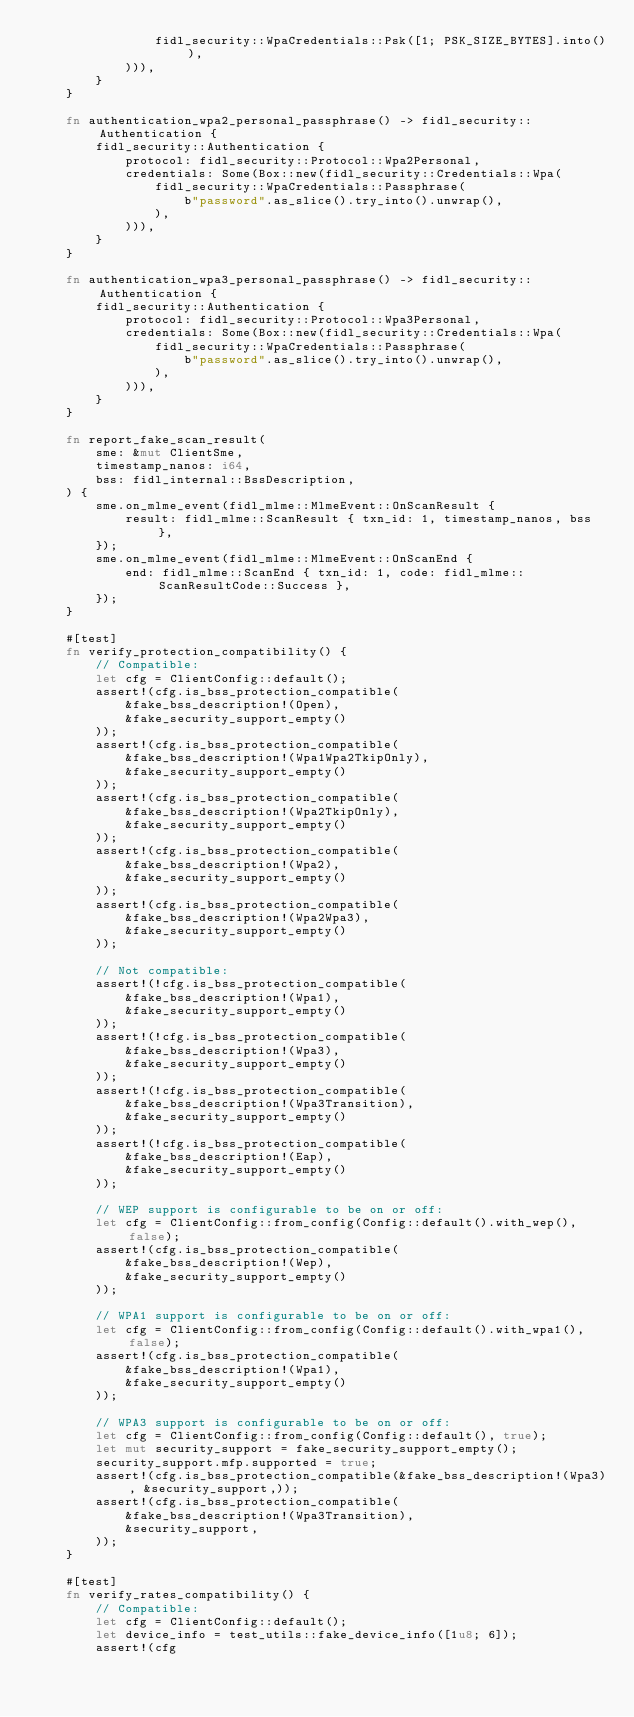<code> <loc_0><loc_0><loc_500><loc_500><_Rust_>                fidl_security::WpaCredentials::Psk([1; PSK_SIZE_BYTES].into()),
            ))),
        }
    }

    fn authentication_wpa2_personal_passphrase() -> fidl_security::Authentication {
        fidl_security::Authentication {
            protocol: fidl_security::Protocol::Wpa2Personal,
            credentials: Some(Box::new(fidl_security::Credentials::Wpa(
                fidl_security::WpaCredentials::Passphrase(
                    b"password".as_slice().try_into().unwrap(),
                ),
            ))),
        }
    }

    fn authentication_wpa3_personal_passphrase() -> fidl_security::Authentication {
        fidl_security::Authentication {
            protocol: fidl_security::Protocol::Wpa3Personal,
            credentials: Some(Box::new(fidl_security::Credentials::Wpa(
                fidl_security::WpaCredentials::Passphrase(
                    b"password".as_slice().try_into().unwrap(),
                ),
            ))),
        }
    }

    fn report_fake_scan_result(
        sme: &mut ClientSme,
        timestamp_nanos: i64,
        bss: fidl_internal::BssDescription,
    ) {
        sme.on_mlme_event(fidl_mlme::MlmeEvent::OnScanResult {
            result: fidl_mlme::ScanResult { txn_id: 1, timestamp_nanos, bss },
        });
        sme.on_mlme_event(fidl_mlme::MlmeEvent::OnScanEnd {
            end: fidl_mlme::ScanEnd { txn_id: 1, code: fidl_mlme::ScanResultCode::Success },
        });
    }

    #[test]
    fn verify_protection_compatibility() {
        // Compatible:
        let cfg = ClientConfig::default();
        assert!(cfg.is_bss_protection_compatible(
            &fake_bss_description!(Open),
            &fake_security_support_empty()
        ));
        assert!(cfg.is_bss_protection_compatible(
            &fake_bss_description!(Wpa1Wpa2TkipOnly),
            &fake_security_support_empty()
        ));
        assert!(cfg.is_bss_protection_compatible(
            &fake_bss_description!(Wpa2TkipOnly),
            &fake_security_support_empty()
        ));
        assert!(cfg.is_bss_protection_compatible(
            &fake_bss_description!(Wpa2),
            &fake_security_support_empty()
        ));
        assert!(cfg.is_bss_protection_compatible(
            &fake_bss_description!(Wpa2Wpa3),
            &fake_security_support_empty()
        ));

        // Not compatible:
        assert!(!cfg.is_bss_protection_compatible(
            &fake_bss_description!(Wpa1),
            &fake_security_support_empty()
        ));
        assert!(!cfg.is_bss_protection_compatible(
            &fake_bss_description!(Wpa3),
            &fake_security_support_empty()
        ));
        assert!(!cfg.is_bss_protection_compatible(
            &fake_bss_description!(Wpa3Transition),
            &fake_security_support_empty()
        ));
        assert!(!cfg.is_bss_protection_compatible(
            &fake_bss_description!(Eap),
            &fake_security_support_empty()
        ));

        // WEP support is configurable to be on or off:
        let cfg = ClientConfig::from_config(Config::default().with_wep(), false);
        assert!(cfg.is_bss_protection_compatible(
            &fake_bss_description!(Wep),
            &fake_security_support_empty()
        ));

        // WPA1 support is configurable to be on or off:
        let cfg = ClientConfig::from_config(Config::default().with_wpa1(), false);
        assert!(cfg.is_bss_protection_compatible(
            &fake_bss_description!(Wpa1),
            &fake_security_support_empty()
        ));

        // WPA3 support is configurable to be on or off:
        let cfg = ClientConfig::from_config(Config::default(), true);
        let mut security_support = fake_security_support_empty();
        security_support.mfp.supported = true;
        assert!(cfg.is_bss_protection_compatible(&fake_bss_description!(Wpa3), &security_support,));
        assert!(cfg.is_bss_protection_compatible(
            &fake_bss_description!(Wpa3Transition),
            &security_support,
        ));
    }

    #[test]
    fn verify_rates_compatibility() {
        // Compatible:
        let cfg = ClientConfig::default();
        let device_info = test_utils::fake_device_info([1u8; 6]);
        assert!(cfg</code> 